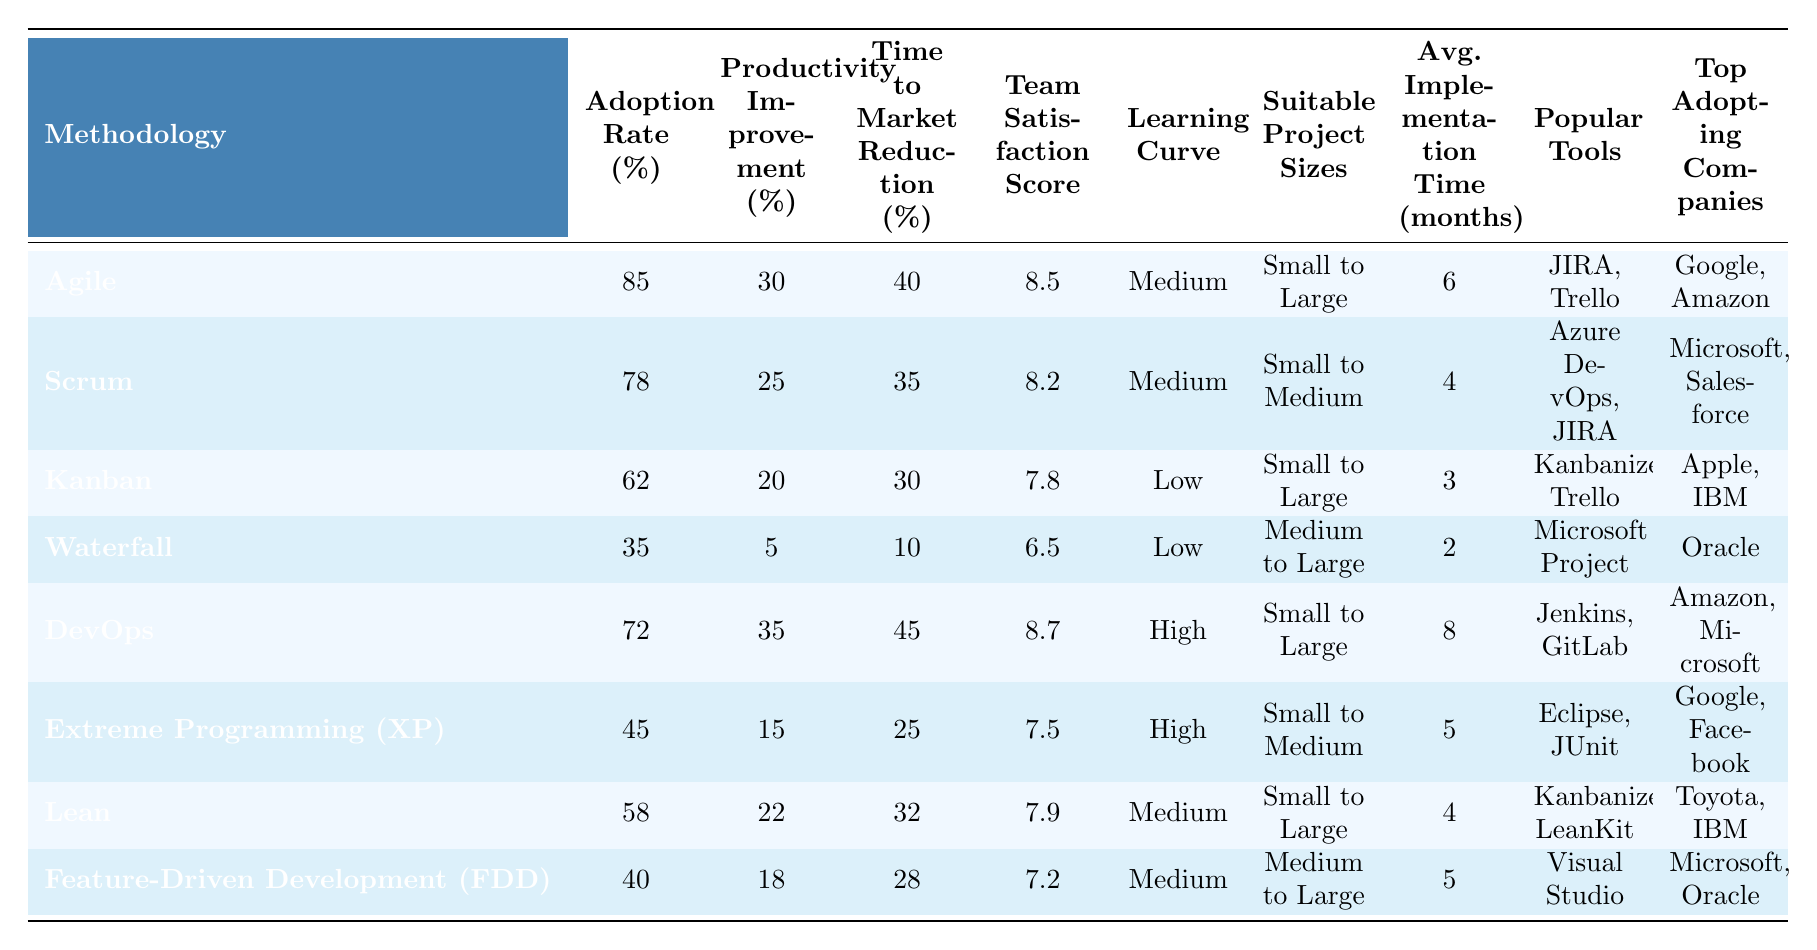What is the adoption rate of Agile methodology? By looking at the table, the adoption rate for Agile is 85%.
Answer: 85% Which methodology has the highest team satisfaction score? The methodology with the highest team satisfaction score is DevOps, with a score of 8.7.
Answer: DevOps What is the average implementation time of the Waterfall methodology? The average implementation time for Waterfall is 2 months.
Answer: 2 months Among the methodologies listed, which has the lowest adoption rate? According to the table, Waterfall has the lowest adoption rate at 35%.
Answer: Waterfall What is the productivity improvement percentage for Scrum? The productivity improvement percentage for Scrum is 25%.
Answer: 25% Is the learning curve for Kanban considered low? Yes, the learning curve for Kanban is labeled as low in the table.
Answer: Yes What is the average team satisfaction score across all methodologies? To find the average team satisfaction score, sum all scores (8.5 + 8.2 + 7.8 + 6.5 + 8.7 + 7.5 + 7.9 + 7.2 = 62.3) and divide by 8, which gives 62.3 / 8 = 7.7875, rounded to 7.79.
Answer: 7.79 Which methodology has both a high learning curve and a high productivity improvement? The methodologies with a high learning curve and high productivity improvement are DevOps (35%) and Extreme Programming (XP) (15%).
Answer: DevOps and Extreme Programming (XP) How much time to market reduction does the DevOps methodology provide compared to Waterfall? DevOps provides a 45% reduction in time to market, while Waterfall provides a 10% reduction. The difference is 45 - 10 = 35%.
Answer: 35% Which company adopts the Kanban methodology? The companies that adopt Kanban are Apple and IBM.
Answer: Apple and IBM What is the relationship between the team satisfaction score and the adoption rate for the Agile methodology? The Agile methodology has a high adoption rate of 85% and a team satisfaction score of 8.5, indicating a positive correlation between high adoption and high satisfaction.
Answer: Positive correlation 